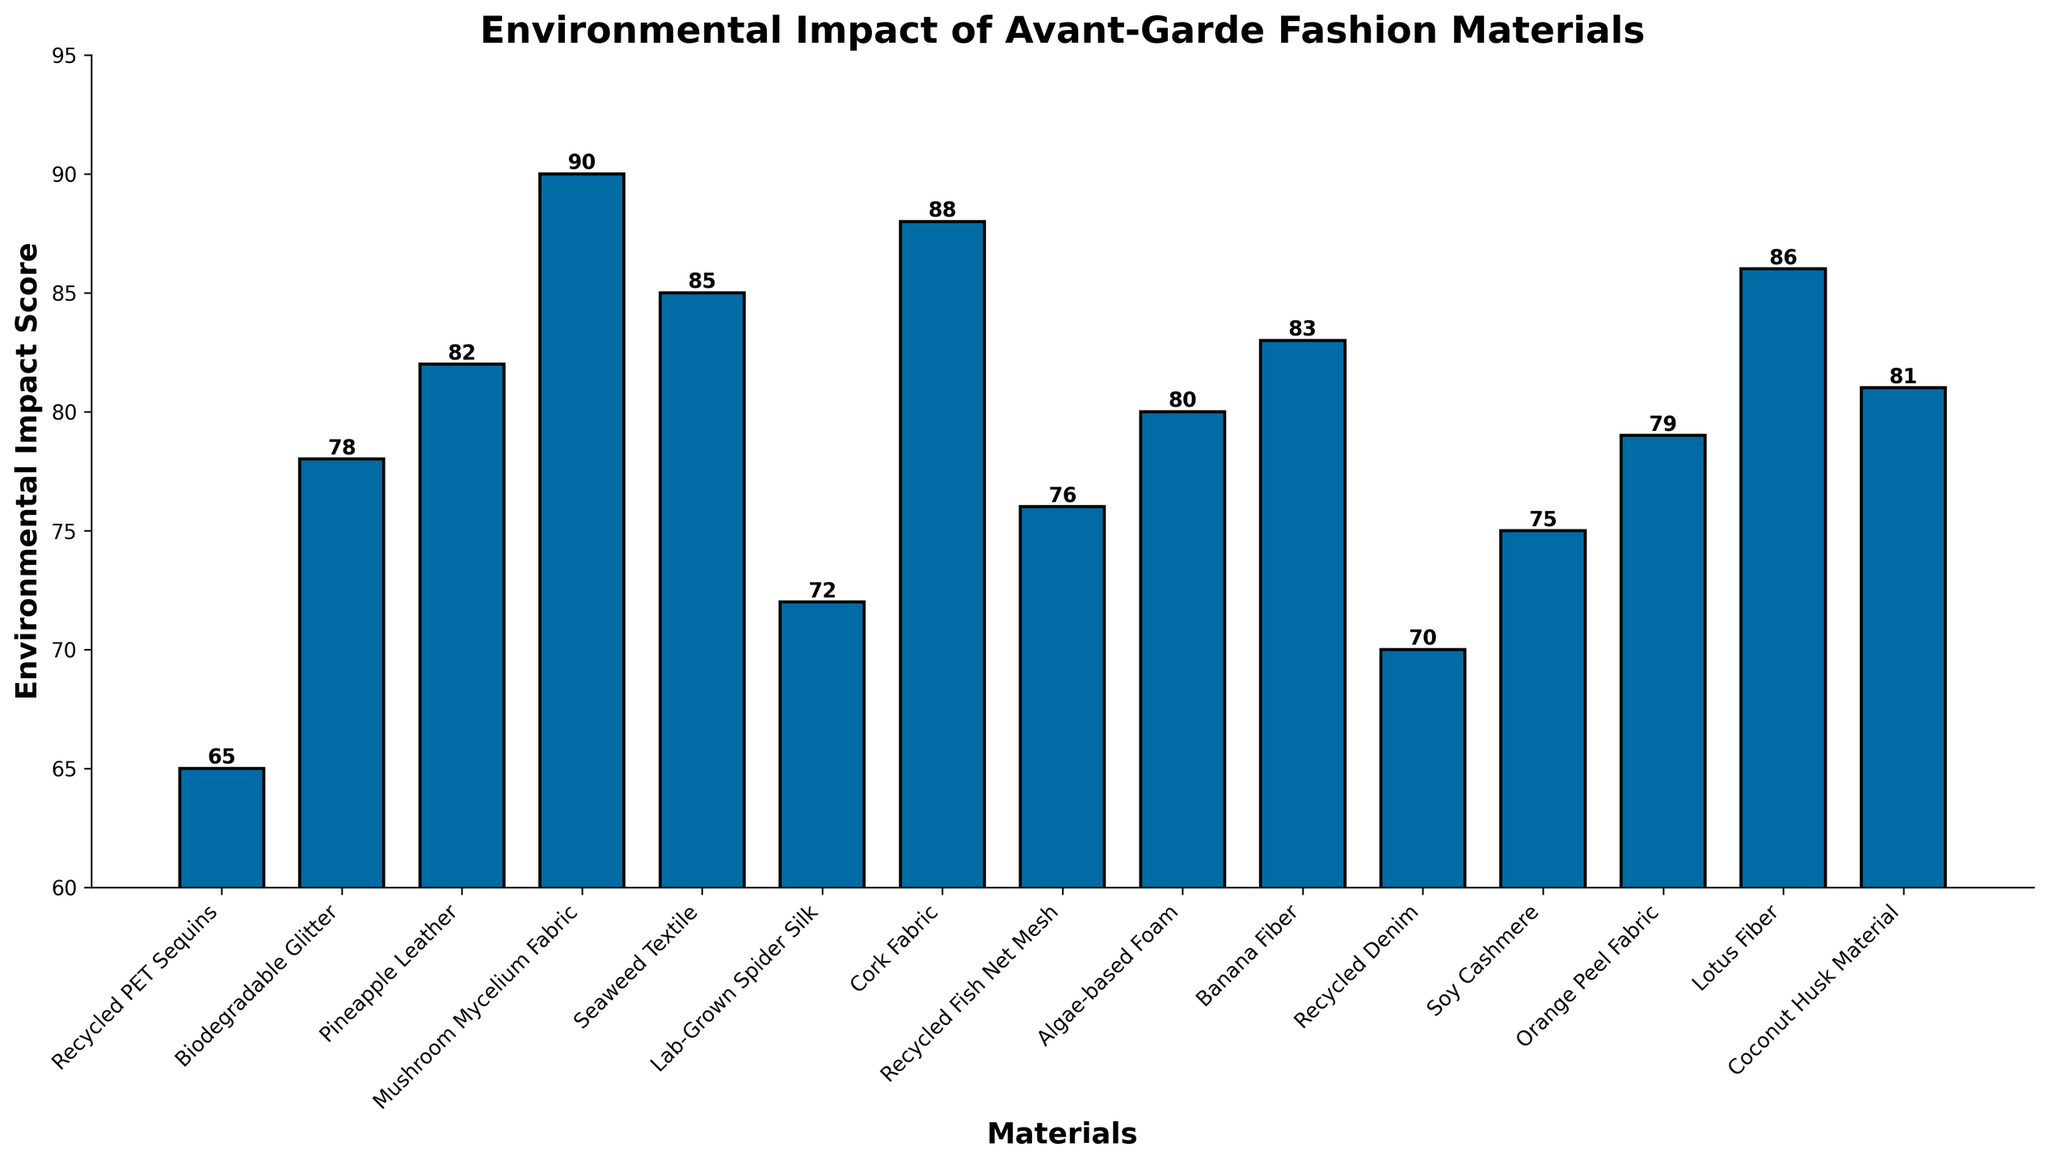Which material has the highest environmental impact score? Identify the bar with the greatest height. The Mushroom Mycelium Fabric bar is the tallest.
Answer: Mushroom Mycelium Fabric Which material has the lowest environmental impact score? Identify the bar with the shortest height. The Recycled PET Sequins bar is the shortest.
Answer: Recycled PET Sequins What is the difference between the environmental impact scores of Pineapple Leather and Recycled PET Sequins? Find the heights (scores) of both bars and subtract the shorter from the taller. Pineapple Leather's score is 82, and Recycled PET Sequins' score is 65. Difference: 82 - 65 = 17.
Answer: 17 How many materials have an environmental impact score greater than 80? Count the number of bars that exceed the 80 value on the y-axis. Pineapple Leather (82), Mushroom Mycelium Fabric (90), Seaweed Textile (85), Banana Fiber (83), Lotus Fiber (86), Coconut Husk Material (81).
Answer: 6 Which two materials have the most similar environmental impact scores? Identify the bars with the closest heights to each other. Recycled Fish Net Mesh (76) and Soy Cashmere (75) have the smallest difference of 1.
Answer: Recycled Fish Net Mesh and Soy Cashmere What's the average environmental impact score of materials with scores below 75? First, identify materials with scores below 75: Recycled PET Sequins (65), Lab-Grown Spider Silk (72), Recycled Denim (70), Soy Cashmere (75). Calculate the average of these scores: (65 + 72 + 70) / 3 = 207 / 3 = 69.
Answer: 69 Which material has a greater environmental impact score: Lab-Grown Spider Silk or Orange Peel Fabric? Compare the heights (scores). Lab-Grown Spider Silk's score is 72, and Orange Peel Fabric's score is 79.
Answer: Orange Peel Fabric What is the combined environmental impact score of Seaweed Textile, Banana Fiber, and Lotus Fiber? Sum the heights (scores) of these bars: Seaweed Textile (85), Banana Fiber (83), Lotus Fiber (86). Total: 85 + 83 + 86 = 254.
Answer: 254 Is the environmental impact score of Recycled Denim closer to that of Lab-Grown Spider Silk or Soy Cashmere? Compare the differences: Recycled Denim (70) and Lab-Grown Spider Silk (72) have a difference of 2, while Recycled Denim (70) and Soy Cashmere (75) have a difference of 5.
Answer: Lab-Grown Spider Silk 